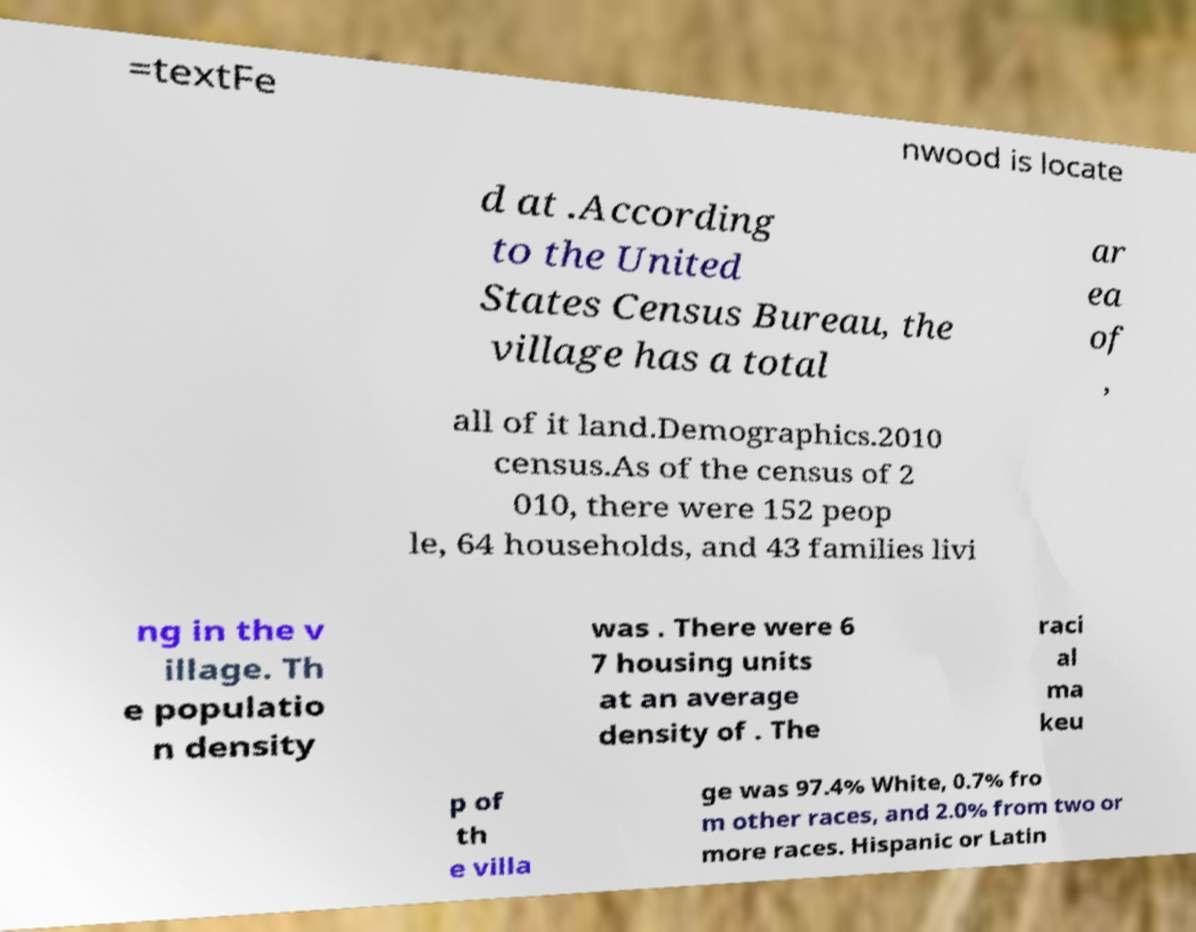Can you accurately transcribe the text from the provided image for me? =textFe nwood is locate d at .According to the United States Census Bureau, the village has a total ar ea of , all of it land.Demographics.2010 census.As of the census of 2 010, there were 152 peop le, 64 households, and 43 families livi ng in the v illage. Th e populatio n density was . There were 6 7 housing units at an average density of . The raci al ma keu p of th e villa ge was 97.4% White, 0.7% fro m other races, and 2.0% from two or more races. Hispanic or Latin 